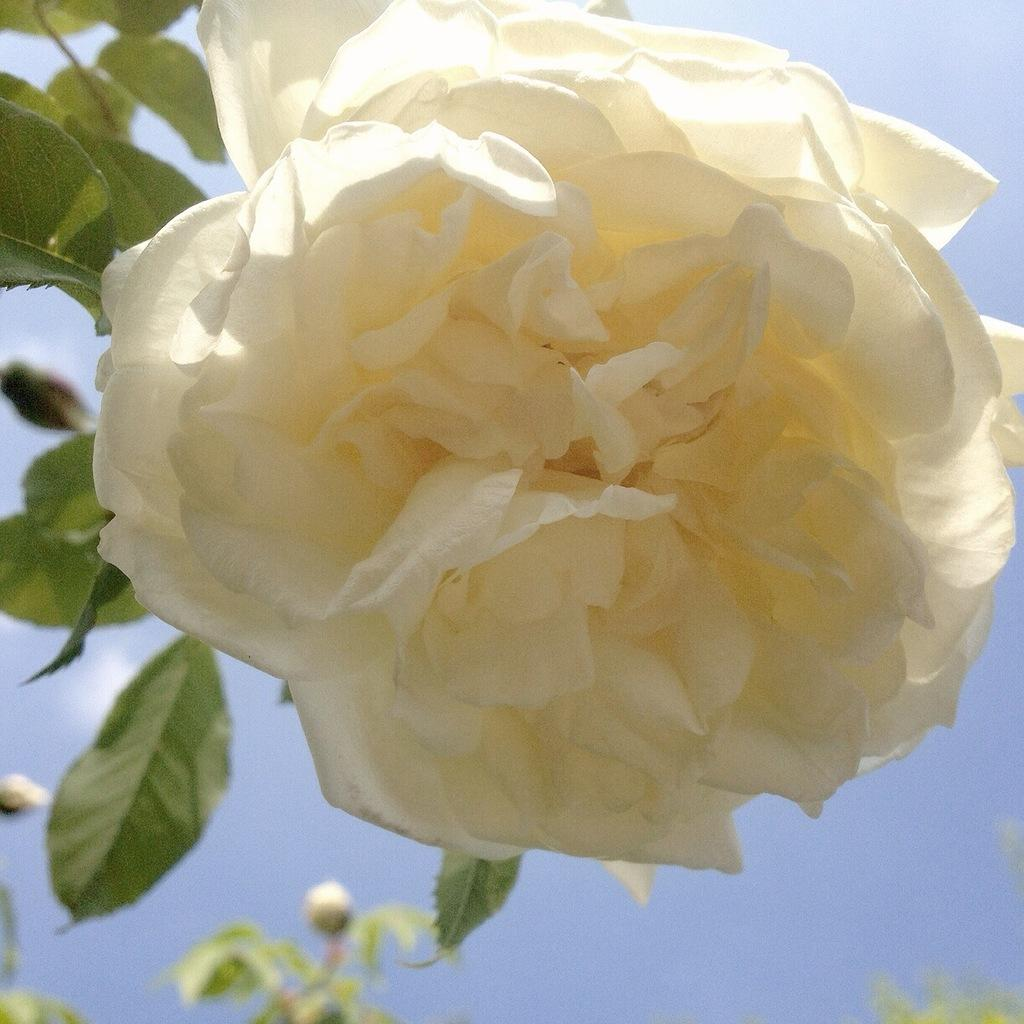What type of flower is in the image? There is a beautiful white color rose flower in the image. Are there any other parts of the rose plant visible in the image? Yes, there are rose buds on the plants in the image. How many parcels can be seen being delivered by the rose flower in the image? There are no parcels visible in the image, as it features a rose flower and rose buds on the plants. Can you tell me if the rose flower is swimming in the image? The rose flower is not swimming in the image; it is a stationary object on the plants. 